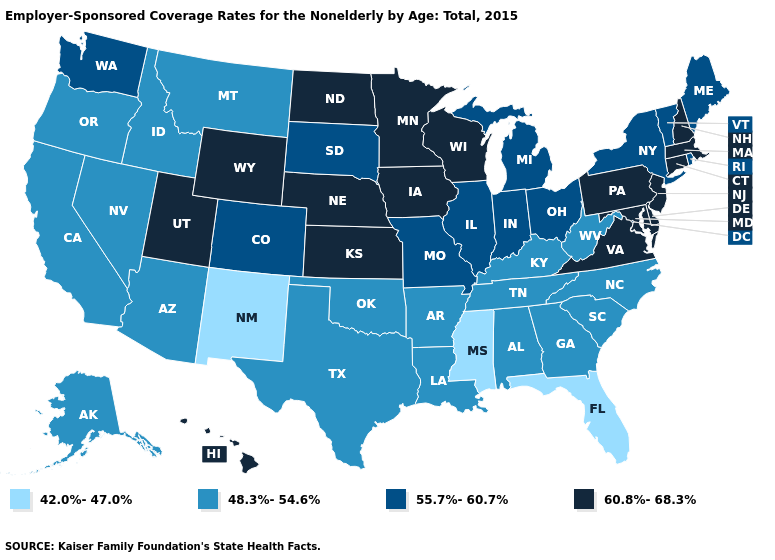Which states have the lowest value in the Northeast?
Short answer required. Maine, New York, Rhode Island, Vermont. What is the value of North Dakota?
Give a very brief answer. 60.8%-68.3%. What is the value of Wisconsin?
Short answer required. 60.8%-68.3%. What is the value of Rhode Island?
Write a very short answer. 55.7%-60.7%. Does Minnesota have the lowest value in the MidWest?
Concise answer only. No. Does Oklahoma have a higher value than South Dakota?
Give a very brief answer. No. How many symbols are there in the legend?
Write a very short answer. 4. What is the value of North Dakota?
Be succinct. 60.8%-68.3%. Name the states that have a value in the range 48.3%-54.6%?
Concise answer only. Alabama, Alaska, Arizona, Arkansas, California, Georgia, Idaho, Kentucky, Louisiana, Montana, Nevada, North Carolina, Oklahoma, Oregon, South Carolina, Tennessee, Texas, West Virginia. Does Illinois have the lowest value in the MidWest?
Be succinct. Yes. What is the value of New Mexico?
Concise answer only. 42.0%-47.0%. Does Kansas have the lowest value in the USA?
Concise answer only. No. Name the states that have a value in the range 42.0%-47.0%?
Keep it brief. Florida, Mississippi, New Mexico. Which states hav the highest value in the MidWest?
Answer briefly. Iowa, Kansas, Minnesota, Nebraska, North Dakota, Wisconsin. Among the states that border Indiana , does Kentucky have the highest value?
Quick response, please. No. 